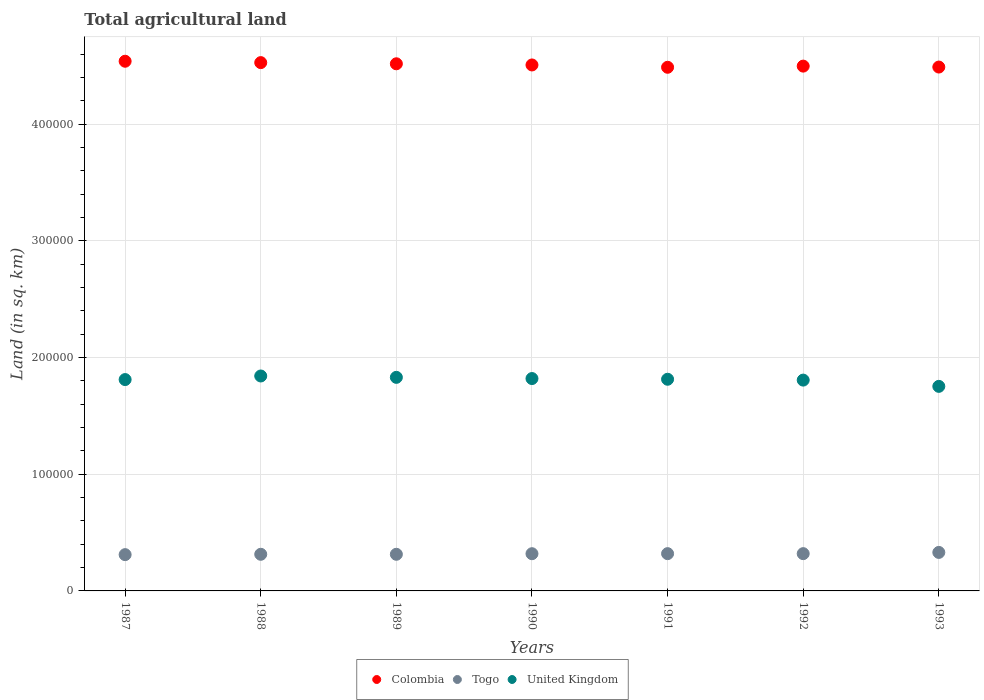What is the total agricultural land in United Kingdom in 1991?
Keep it short and to the point. 1.81e+05. Across all years, what is the maximum total agricultural land in Togo?
Your answer should be compact. 3.30e+04. Across all years, what is the minimum total agricultural land in Togo?
Your answer should be very brief. 3.11e+04. In which year was the total agricultural land in Colombia maximum?
Offer a terse response. 1987. In which year was the total agricultural land in Colombia minimum?
Offer a very short reply. 1991. What is the total total agricultural land in Colombia in the graph?
Provide a short and direct response. 3.16e+06. What is the difference between the total agricultural land in Togo in 1989 and that in 1991?
Provide a short and direct response. -550. What is the difference between the total agricultural land in Colombia in 1991 and the total agricultural land in Togo in 1987?
Keep it short and to the point. 4.18e+05. What is the average total agricultural land in Colombia per year?
Provide a succinct answer. 4.51e+05. In the year 1991, what is the difference between the total agricultural land in Colombia and total agricultural land in United Kingdom?
Your answer should be compact. 2.67e+05. In how many years, is the total agricultural land in United Kingdom greater than 200000 sq.km?
Your response must be concise. 0. What is the ratio of the total agricultural land in Togo in 1988 to that in 1991?
Your response must be concise. 0.98. Is the difference between the total agricultural land in Colombia in 1987 and 1992 greater than the difference between the total agricultural land in United Kingdom in 1987 and 1992?
Offer a very short reply. Yes. What is the difference between the highest and the second highest total agricultural land in Colombia?
Provide a succinct answer. 1180. What is the difference between the highest and the lowest total agricultural land in United Kingdom?
Ensure brevity in your answer.  8890. Is it the case that in every year, the sum of the total agricultural land in United Kingdom and total agricultural land in Colombia  is greater than the total agricultural land in Togo?
Ensure brevity in your answer.  Yes. Is the total agricultural land in United Kingdom strictly less than the total agricultural land in Colombia over the years?
Offer a terse response. Yes. How many years are there in the graph?
Your answer should be compact. 7. Are the values on the major ticks of Y-axis written in scientific E-notation?
Ensure brevity in your answer.  No. Does the graph contain any zero values?
Keep it short and to the point. No. Does the graph contain grids?
Provide a short and direct response. Yes. Where does the legend appear in the graph?
Make the answer very short. Bottom center. What is the title of the graph?
Your answer should be very brief. Total agricultural land. What is the label or title of the X-axis?
Provide a succinct answer. Years. What is the label or title of the Y-axis?
Ensure brevity in your answer.  Land (in sq. km). What is the Land (in sq. km) in Colombia in 1987?
Provide a short and direct response. 4.54e+05. What is the Land (in sq. km) in Togo in 1987?
Make the answer very short. 3.11e+04. What is the Land (in sq. km) of United Kingdom in 1987?
Ensure brevity in your answer.  1.81e+05. What is the Land (in sq. km) of Colombia in 1988?
Provide a short and direct response. 4.53e+05. What is the Land (in sq. km) of Togo in 1988?
Provide a succinct answer. 3.14e+04. What is the Land (in sq. km) in United Kingdom in 1988?
Give a very brief answer. 1.84e+05. What is the Land (in sq. km) in Colombia in 1989?
Make the answer very short. 4.52e+05. What is the Land (in sq. km) of Togo in 1989?
Keep it short and to the point. 3.14e+04. What is the Land (in sq. km) of United Kingdom in 1989?
Provide a succinct answer. 1.83e+05. What is the Land (in sq. km) in Colombia in 1990?
Keep it short and to the point. 4.51e+05. What is the Land (in sq. km) of Togo in 1990?
Provide a succinct answer. 3.19e+04. What is the Land (in sq. km) of United Kingdom in 1990?
Offer a very short reply. 1.82e+05. What is the Land (in sq. km) of Colombia in 1991?
Offer a terse response. 4.49e+05. What is the Land (in sq. km) of Togo in 1991?
Your response must be concise. 3.20e+04. What is the Land (in sq. km) of United Kingdom in 1991?
Provide a succinct answer. 1.81e+05. What is the Land (in sq. km) in Colombia in 1992?
Your answer should be compact. 4.50e+05. What is the Land (in sq. km) of Togo in 1992?
Provide a short and direct response. 3.20e+04. What is the Land (in sq. km) in United Kingdom in 1992?
Provide a succinct answer. 1.81e+05. What is the Land (in sq. km) of Colombia in 1993?
Make the answer very short. 4.49e+05. What is the Land (in sq. km) in Togo in 1993?
Offer a terse response. 3.30e+04. What is the Land (in sq. km) in United Kingdom in 1993?
Ensure brevity in your answer.  1.75e+05. Across all years, what is the maximum Land (in sq. km) in Colombia?
Provide a succinct answer. 4.54e+05. Across all years, what is the maximum Land (in sq. km) in Togo?
Ensure brevity in your answer.  3.30e+04. Across all years, what is the maximum Land (in sq. km) of United Kingdom?
Give a very brief answer. 1.84e+05. Across all years, what is the minimum Land (in sq. km) in Colombia?
Offer a terse response. 4.49e+05. Across all years, what is the minimum Land (in sq. km) of Togo?
Your response must be concise. 3.11e+04. Across all years, what is the minimum Land (in sq. km) in United Kingdom?
Offer a terse response. 1.75e+05. What is the total Land (in sq. km) in Colombia in the graph?
Offer a terse response. 3.16e+06. What is the total Land (in sq. km) of Togo in the graph?
Keep it short and to the point. 2.23e+05. What is the total Land (in sq. km) of United Kingdom in the graph?
Provide a short and direct response. 1.27e+06. What is the difference between the Land (in sq. km) of Colombia in 1987 and that in 1988?
Offer a terse response. 1180. What is the difference between the Land (in sq. km) of Togo in 1987 and that in 1988?
Make the answer very short. -300. What is the difference between the Land (in sq. km) in United Kingdom in 1987 and that in 1988?
Make the answer very short. -3070. What is the difference between the Land (in sq. km) of Colombia in 1987 and that in 1989?
Offer a very short reply. 2180. What is the difference between the Land (in sq. km) of Togo in 1987 and that in 1989?
Your response must be concise. -300. What is the difference between the Land (in sq. km) in United Kingdom in 1987 and that in 1989?
Provide a succinct answer. -1900. What is the difference between the Land (in sq. km) in Colombia in 1987 and that in 1990?
Make the answer very short. 3180. What is the difference between the Land (in sq. km) in Togo in 1987 and that in 1990?
Provide a short and direct response. -800. What is the difference between the Land (in sq. km) of United Kingdom in 1987 and that in 1990?
Make the answer very short. -870. What is the difference between the Land (in sq. km) of Colombia in 1987 and that in 1991?
Provide a short and direct response. 5170. What is the difference between the Land (in sq. km) in Togo in 1987 and that in 1991?
Offer a very short reply. -850. What is the difference between the Land (in sq. km) of United Kingdom in 1987 and that in 1991?
Keep it short and to the point. -270. What is the difference between the Land (in sq. km) in Colombia in 1987 and that in 1992?
Keep it short and to the point. 4180. What is the difference between the Land (in sq. km) of Togo in 1987 and that in 1992?
Make the answer very short. -850. What is the difference between the Land (in sq. km) of United Kingdom in 1987 and that in 1992?
Your answer should be very brief. 460. What is the difference between the Land (in sq. km) of Colombia in 1987 and that in 1993?
Offer a very short reply. 4980. What is the difference between the Land (in sq. km) in Togo in 1987 and that in 1993?
Your response must be concise. -1900. What is the difference between the Land (in sq. km) of United Kingdom in 1987 and that in 1993?
Your answer should be compact. 5820. What is the difference between the Land (in sq. km) in United Kingdom in 1988 and that in 1989?
Your answer should be compact. 1170. What is the difference between the Land (in sq. km) in Togo in 1988 and that in 1990?
Provide a succinct answer. -500. What is the difference between the Land (in sq. km) in United Kingdom in 1988 and that in 1990?
Provide a short and direct response. 2200. What is the difference between the Land (in sq. km) in Colombia in 1988 and that in 1991?
Give a very brief answer. 3990. What is the difference between the Land (in sq. km) of Togo in 1988 and that in 1991?
Provide a succinct answer. -550. What is the difference between the Land (in sq. km) in United Kingdom in 1988 and that in 1991?
Ensure brevity in your answer.  2800. What is the difference between the Land (in sq. km) of Colombia in 1988 and that in 1992?
Offer a terse response. 3000. What is the difference between the Land (in sq. km) in Togo in 1988 and that in 1992?
Your answer should be very brief. -550. What is the difference between the Land (in sq. km) in United Kingdom in 1988 and that in 1992?
Keep it short and to the point. 3530. What is the difference between the Land (in sq. km) of Colombia in 1988 and that in 1993?
Ensure brevity in your answer.  3800. What is the difference between the Land (in sq. km) in Togo in 1988 and that in 1993?
Make the answer very short. -1600. What is the difference between the Land (in sq. km) in United Kingdom in 1988 and that in 1993?
Provide a succinct answer. 8890. What is the difference between the Land (in sq. km) of Colombia in 1989 and that in 1990?
Provide a succinct answer. 1000. What is the difference between the Land (in sq. km) of Togo in 1989 and that in 1990?
Provide a succinct answer. -500. What is the difference between the Land (in sq. km) of United Kingdom in 1989 and that in 1990?
Provide a short and direct response. 1030. What is the difference between the Land (in sq. km) of Colombia in 1989 and that in 1991?
Offer a very short reply. 2990. What is the difference between the Land (in sq. km) in Togo in 1989 and that in 1991?
Provide a succinct answer. -550. What is the difference between the Land (in sq. km) of United Kingdom in 1989 and that in 1991?
Keep it short and to the point. 1630. What is the difference between the Land (in sq. km) of Colombia in 1989 and that in 1992?
Provide a succinct answer. 2000. What is the difference between the Land (in sq. km) in Togo in 1989 and that in 1992?
Your answer should be compact. -550. What is the difference between the Land (in sq. km) in United Kingdom in 1989 and that in 1992?
Your response must be concise. 2360. What is the difference between the Land (in sq. km) of Colombia in 1989 and that in 1993?
Make the answer very short. 2800. What is the difference between the Land (in sq. km) in Togo in 1989 and that in 1993?
Provide a succinct answer. -1600. What is the difference between the Land (in sq. km) in United Kingdom in 1989 and that in 1993?
Provide a succinct answer. 7720. What is the difference between the Land (in sq. km) of Colombia in 1990 and that in 1991?
Offer a very short reply. 1990. What is the difference between the Land (in sq. km) in United Kingdom in 1990 and that in 1991?
Offer a very short reply. 600. What is the difference between the Land (in sq. km) in Togo in 1990 and that in 1992?
Keep it short and to the point. -50. What is the difference between the Land (in sq. km) in United Kingdom in 1990 and that in 1992?
Provide a succinct answer. 1330. What is the difference between the Land (in sq. km) in Colombia in 1990 and that in 1993?
Keep it short and to the point. 1800. What is the difference between the Land (in sq. km) in Togo in 1990 and that in 1993?
Provide a short and direct response. -1100. What is the difference between the Land (in sq. km) of United Kingdom in 1990 and that in 1993?
Ensure brevity in your answer.  6690. What is the difference between the Land (in sq. km) of Colombia in 1991 and that in 1992?
Provide a short and direct response. -990. What is the difference between the Land (in sq. km) of Togo in 1991 and that in 1992?
Give a very brief answer. 0. What is the difference between the Land (in sq. km) in United Kingdom in 1991 and that in 1992?
Your answer should be compact. 730. What is the difference between the Land (in sq. km) in Colombia in 1991 and that in 1993?
Offer a very short reply. -190. What is the difference between the Land (in sq. km) of Togo in 1991 and that in 1993?
Provide a succinct answer. -1050. What is the difference between the Land (in sq. km) in United Kingdom in 1991 and that in 1993?
Provide a short and direct response. 6090. What is the difference between the Land (in sq. km) in Colombia in 1992 and that in 1993?
Make the answer very short. 800. What is the difference between the Land (in sq. km) of Togo in 1992 and that in 1993?
Give a very brief answer. -1050. What is the difference between the Land (in sq. km) of United Kingdom in 1992 and that in 1993?
Your response must be concise. 5360. What is the difference between the Land (in sq. km) of Colombia in 1987 and the Land (in sq. km) of Togo in 1988?
Provide a short and direct response. 4.23e+05. What is the difference between the Land (in sq. km) of Colombia in 1987 and the Land (in sq. km) of United Kingdom in 1988?
Make the answer very short. 2.70e+05. What is the difference between the Land (in sq. km) in Togo in 1987 and the Land (in sq. km) in United Kingdom in 1988?
Offer a terse response. -1.53e+05. What is the difference between the Land (in sq. km) in Colombia in 1987 and the Land (in sq. km) in Togo in 1989?
Ensure brevity in your answer.  4.23e+05. What is the difference between the Land (in sq. km) of Colombia in 1987 and the Land (in sq. km) of United Kingdom in 1989?
Provide a succinct answer. 2.71e+05. What is the difference between the Land (in sq. km) of Togo in 1987 and the Land (in sq. km) of United Kingdom in 1989?
Make the answer very short. -1.52e+05. What is the difference between the Land (in sq. km) of Colombia in 1987 and the Land (in sq. km) of Togo in 1990?
Your response must be concise. 4.22e+05. What is the difference between the Land (in sq. km) of Colombia in 1987 and the Land (in sq. km) of United Kingdom in 1990?
Ensure brevity in your answer.  2.72e+05. What is the difference between the Land (in sq. km) in Togo in 1987 and the Land (in sq. km) in United Kingdom in 1990?
Offer a very short reply. -1.51e+05. What is the difference between the Land (in sq. km) of Colombia in 1987 and the Land (in sq. km) of Togo in 1991?
Your answer should be compact. 4.22e+05. What is the difference between the Land (in sq. km) of Colombia in 1987 and the Land (in sq. km) of United Kingdom in 1991?
Offer a terse response. 2.73e+05. What is the difference between the Land (in sq. km) of Togo in 1987 and the Land (in sq. km) of United Kingdom in 1991?
Provide a short and direct response. -1.50e+05. What is the difference between the Land (in sq. km) in Colombia in 1987 and the Land (in sq. km) in Togo in 1992?
Keep it short and to the point. 4.22e+05. What is the difference between the Land (in sq. km) of Colombia in 1987 and the Land (in sq. km) of United Kingdom in 1992?
Keep it short and to the point. 2.73e+05. What is the difference between the Land (in sq. km) in Togo in 1987 and the Land (in sq. km) in United Kingdom in 1992?
Provide a succinct answer. -1.50e+05. What is the difference between the Land (in sq. km) in Colombia in 1987 and the Land (in sq. km) in Togo in 1993?
Give a very brief answer. 4.21e+05. What is the difference between the Land (in sq. km) of Colombia in 1987 and the Land (in sq. km) of United Kingdom in 1993?
Your answer should be compact. 2.79e+05. What is the difference between the Land (in sq. km) of Togo in 1987 and the Land (in sq. km) of United Kingdom in 1993?
Provide a short and direct response. -1.44e+05. What is the difference between the Land (in sq. km) in Colombia in 1988 and the Land (in sq. km) in Togo in 1989?
Keep it short and to the point. 4.21e+05. What is the difference between the Land (in sq. km) of Colombia in 1988 and the Land (in sq. km) of United Kingdom in 1989?
Make the answer very short. 2.70e+05. What is the difference between the Land (in sq. km) in Togo in 1988 and the Land (in sq. km) in United Kingdom in 1989?
Your response must be concise. -1.52e+05. What is the difference between the Land (in sq. km) of Colombia in 1988 and the Land (in sq. km) of Togo in 1990?
Your answer should be compact. 4.21e+05. What is the difference between the Land (in sq. km) in Colombia in 1988 and the Land (in sq. km) in United Kingdom in 1990?
Keep it short and to the point. 2.71e+05. What is the difference between the Land (in sq. km) of Togo in 1988 and the Land (in sq. km) of United Kingdom in 1990?
Offer a terse response. -1.51e+05. What is the difference between the Land (in sq. km) of Colombia in 1988 and the Land (in sq. km) of Togo in 1991?
Provide a short and direct response. 4.21e+05. What is the difference between the Land (in sq. km) in Colombia in 1988 and the Land (in sq. km) in United Kingdom in 1991?
Ensure brevity in your answer.  2.71e+05. What is the difference between the Land (in sq. km) of Togo in 1988 and the Land (in sq. km) of United Kingdom in 1991?
Offer a very short reply. -1.50e+05. What is the difference between the Land (in sq. km) in Colombia in 1988 and the Land (in sq. km) in Togo in 1992?
Ensure brevity in your answer.  4.21e+05. What is the difference between the Land (in sq. km) in Colombia in 1988 and the Land (in sq. km) in United Kingdom in 1992?
Offer a terse response. 2.72e+05. What is the difference between the Land (in sq. km) in Togo in 1988 and the Land (in sq. km) in United Kingdom in 1992?
Provide a short and direct response. -1.49e+05. What is the difference between the Land (in sq. km) of Colombia in 1988 and the Land (in sq. km) of Togo in 1993?
Provide a succinct answer. 4.20e+05. What is the difference between the Land (in sq. km) in Colombia in 1988 and the Land (in sq. km) in United Kingdom in 1993?
Keep it short and to the point. 2.77e+05. What is the difference between the Land (in sq. km) of Togo in 1988 and the Land (in sq. km) of United Kingdom in 1993?
Offer a very short reply. -1.44e+05. What is the difference between the Land (in sq. km) of Colombia in 1989 and the Land (in sq. km) of Togo in 1990?
Provide a succinct answer. 4.20e+05. What is the difference between the Land (in sq. km) in Colombia in 1989 and the Land (in sq. km) in United Kingdom in 1990?
Ensure brevity in your answer.  2.70e+05. What is the difference between the Land (in sq. km) in Togo in 1989 and the Land (in sq. km) in United Kingdom in 1990?
Offer a terse response. -1.51e+05. What is the difference between the Land (in sq. km) of Colombia in 1989 and the Land (in sq. km) of Togo in 1991?
Offer a terse response. 4.20e+05. What is the difference between the Land (in sq. km) in Colombia in 1989 and the Land (in sq. km) in United Kingdom in 1991?
Provide a short and direct response. 2.70e+05. What is the difference between the Land (in sq. km) of Togo in 1989 and the Land (in sq. km) of United Kingdom in 1991?
Make the answer very short. -1.50e+05. What is the difference between the Land (in sq. km) in Colombia in 1989 and the Land (in sq. km) in Togo in 1992?
Offer a very short reply. 4.20e+05. What is the difference between the Land (in sq. km) in Colombia in 1989 and the Land (in sq. km) in United Kingdom in 1992?
Offer a terse response. 2.71e+05. What is the difference between the Land (in sq. km) of Togo in 1989 and the Land (in sq. km) of United Kingdom in 1992?
Keep it short and to the point. -1.49e+05. What is the difference between the Land (in sq. km) in Colombia in 1989 and the Land (in sq. km) in Togo in 1993?
Provide a succinct answer. 4.19e+05. What is the difference between the Land (in sq. km) in Colombia in 1989 and the Land (in sq. km) in United Kingdom in 1993?
Make the answer very short. 2.76e+05. What is the difference between the Land (in sq. km) of Togo in 1989 and the Land (in sq. km) of United Kingdom in 1993?
Keep it short and to the point. -1.44e+05. What is the difference between the Land (in sq. km) of Colombia in 1990 and the Land (in sq. km) of Togo in 1991?
Ensure brevity in your answer.  4.19e+05. What is the difference between the Land (in sq. km) in Colombia in 1990 and the Land (in sq. km) in United Kingdom in 1991?
Offer a terse response. 2.69e+05. What is the difference between the Land (in sq. km) in Togo in 1990 and the Land (in sq. km) in United Kingdom in 1991?
Provide a succinct answer. -1.50e+05. What is the difference between the Land (in sq. km) of Colombia in 1990 and the Land (in sq. km) of Togo in 1992?
Offer a terse response. 4.19e+05. What is the difference between the Land (in sq. km) in Colombia in 1990 and the Land (in sq. km) in United Kingdom in 1992?
Provide a short and direct response. 2.70e+05. What is the difference between the Land (in sq. km) of Togo in 1990 and the Land (in sq. km) of United Kingdom in 1992?
Make the answer very short. -1.49e+05. What is the difference between the Land (in sq. km) of Colombia in 1990 and the Land (in sq. km) of Togo in 1993?
Provide a short and direct response. 4.18e+05. What is the difference between the Land (in sq. km) in Colombia in 1990 and the Land (in sq. km) in United Kingdom in 1993?
Your answer should be compact. 2.75e+05. What is the difference between the Land (in sq. km) in Togo in 1990 and the Land (in sq. km) in United Kingdom in 1993?
Provide a short and direct response. -1.43e+05. What is the difference between the Land (in sq. km) of Colombia in 1991 and the Land (in sq. km) of Togo in 1992?
Provide a succinct answer. 4.17e+05. What is the difference between the Land (in sq. km) of Colombia in 1991 and the Land (in sq. km) of United Kingdom in 1992?
Keep it short and to the point. 2.68e+05. What is the difference between the Land (in sq. km) of Togo in 1991 and the Land (in sq. km) of United Kingdom in 1992?
Keep it short and to the point. -1.49e+05. What is the difference between the Land (in sq. km) of Colombia in 1991 and the Land (in sq. km) of Togo in 1993?
Your response must be concise. 4.16e+05. What is the difference between the Land (in sq. km) of Colombia in 1991 and the Land (in sq. km) of United Kingdom in 1993?
Keep it short and to the point. 2.74e+05. What is the difference between the Land (in sq. km) in Togo in 1991 and the Land (in sq. km) in United Kingdom in 1993?
Give a very brief answer. -1.43e+05. What is the difference between the Land (in sq. km) of Colombia in 1992 and the Land (in sq. km) of Togo in 1993?
Your response must be concise. 4.17e+05. What is the difference between the Land (in sq. km) in Colombia in 1992 and the Land (in sq. km) in United Kingdom in 1993?
Your response must be concise. 2.74e+05. What is the difference between the Land (in sq. km) in Togo in 1992 and the Land (in sq. km) in United Kingdom in 1993?
Keep it short and to the point. -1.43e+05. What is the average Land (in sq. km) of Colombia per year?
Offer a very short reply. 4.51e+05. What is the average Land (in sq. km) of Togo per year?
Give a very brief answer. 3.18e+04. What is the average Land (in sq. km) in United Kingdom per year?
Keep it short and to the point. 1.81e+05. In the year 1987, what is the difference between the Land (in sq. km) of Colombia and Land (in sq. km) of Togo?
Keep it short and to the point. 4.23e+05. In the year 1987, what is the difference between the Land (in sq. km) of Colombia and Land (in sq. km) of United Kingdom?
Your answer should be compact. 2.73e+05. In the year 1987, what is the difference between the Land (in sq. km) in Togo and Land (in sq. km) in United Kingdom?
Give a very brief answer. -1.50e+05. In the year 1988, what is the difference between the Land (in sq. km) of Colombia and Land (in sq. km) of Togo?
Your answer should be very brief. 4.21e+05. In the year 1988, what is the difference between the Land (in sq. km) in Colombia and Land (in sq. km) in United Kingdom?
Offer a very short reply. 2.69e+05. In the year 1988, what is the difference between the Land (in sq. km) of Togo and Land (in sq. km) of United Kingdom?
Your answer should be very brief. -1.53e+05. In the year 1989, what is the difference between the Land (in sq. km) of Colombia and Land (in sq. km) of Togo?
Make the answer very short. 4.20e+05. In the year 1989, what is the difference between the Land (in sq. km) of Colombia and Land (in sq. km) of United Kingdom?
Provide a succinct answer. 2.69e+05. In the year 1989, what is the difference between the Land (in sq. km) of Togo and Land (in sq. km) of United Kingdom?
Your answer should be very brief. -1.52e+05. In the year 1990, what is the difference between the Land (in sq. km) of Colombia and Land (in sq. km) of Togo?
Offer a terse response. 4.19e+05. In the year 1990, what is the difference between the Land (in sq. km) of Colombia and Land (in sq. km) of United Kingdom?
Provide a short and direct response. 2.69e+05. In the year 1990, what is the difference between the Land (in sq. km) in Togo and Land (in sq. km) in United Kingdom?
Provide a short and direct response. -1.50e+05. In the year 1991, what is the difference between the Land (in sq. km) of Colombia and Land (in sq. km) of Togo?
Give a very brief answer. 4.17e+05. In the year 1991, what is the difference between the Land (in sq. km) of Colombia and Land (in sq. km) of United Kingdom?
Keep it short and to the point. 2.67e+05. In the year 1991, what is the difference between the Land (in sq. km) of Togo and Land (in sq. km) of United Kingdom?
Keep it short and to the point. -1.49e+05. In the year 1992, what is the difference between the Land (in sq. km) of Colombia and Land (in sq. km) of Togo?
Keep it short and to the point. 4.18e+05. In the year 1992, what is the difference between the Land (in sq. km) of Colombia and Land (in sq. km) of United Kingdom?
Ensure brevity in your answer.  2.69e+05. In the year 1992, what is the difference between the Land (in sq. km) in Togo and Land (in sq. km) in United Kingdom?
Keep it short and to the point. -1.49e+05. In the year 1993, what is the difference between the Land (in sq. km) of Colombia and Land (in sq. km) of Togo?
Provide a short and direct response. 4.16e+05. In the year 1993, what is the difference between the Land (in sq. km) of Colombia and Land (in sq. km) of United Kingdom?
Provide a short and direct response. 2.74e+05. In the year 1993, what is the difference between the Land (in sq. km) of Togo and Land (in sq. km) of United Kingdom?
Give a very brief answer. -1.42e+05. What is the ratio of the Land (in sq. km) of Colombia in 1987 to that in 1988?
Your answer should be very brief. 1. What is the ratio of the Land (in sq. km) in United Kingdom in 1987 to that in 1988?
Your response must be concise. 0.98. What is the ratio of the Land (in sq. km) of Colombia in 1987 to that in 1989?
Provide a succinct answer. 1. What is the ratio of the Land (in sq. km) in United Kingdom in 1987 to that in 1989?
Keep it short and to the point. 0.99. What is the ratio of the Land (in sq. km) of Colombia in 1987 to that in 1990?
Your answer should be compact. 1.01. What is the ratio of the Land (in sq. km) in Togo in 1987 to that in 1990?
Provide a short and direct response. 0.97. What is the ratio of the Land (in sq. km) in Colombia in 1987 to that in 1991?
Keep it short and to the point. 1.01. What is the ratio of the Land (in sq. km) in Togo in 1987 to that in 1991?
Keep it short and to the point. 0.97. What is the ratio of the Land (in sq. km) in Colombia in 1987 to that in 1992?
Ensure brevity in your answer.  1.01. What is the ratio of the Land (in sq. km) in Togo in 1987 to that in 1992?
Keep it short and to the point. 0.97. What is the ratio of the Land (in sq. km) of United Kingdom in 1987 to that in 1992?
Give a very brief answer. 1. What is the ratio of the Land (in sq. km) in Colombia in 1987 to that in 1993?
Offer a terse response. 1.01. What is the ratio of the Land (in sq. km) in Togo in 1987 to that in 1993?
Your response must be concise. 0.94. What is the ratio of the Land (in sq. km) of United Kingdom in 1987 to that in 1993?
Offer a very short reply. 1.03. What is the ratio of the Land (in sq. km) of Colombia in 1988 to that in 1989?
Provide a short and direct response. 1. What is the ratio of the Land (in sq. km) of United Kingdom in 1988 to that in 1989?
Your response must be concise. 1.01. What is the ratio of the Land (in sq. km) of Colombia in 1988 to that in 1990?
Provide a short and direct response. 1. What is the ratio of the Land (in sq. km) of Togo in 1988 to that in 1990?
Ensure brevity in your answer.  0.98. What is the ratio of the Land (in sq. km) of United Kingdom in 1988 to that in 1990?
Give a very brief answer. 1.01. What is the ratio of the Land (in sq. km) of Colombia in 1988 to that in 1991?
Provide a succinct answer. 1.01. What is the ratio of the Land (in sq. km) in Togo in 1988 to that in 1991?
Your response must be concise. 0.98. What is the ratio of the Land (in sq. km) in United Kingdom in 1988 to that in 1991?
Offer a terse response. 1.02. What is the ratio of the Land (in sq. km) in Colombia in 1988 to that in 1992?
Give a very brief answer. 1.01. What is the ratio of the Land (in sq. km) in Togo in 1988 to that in 1992?
Provide a succinct answer. 0.98. What is the ratio of the Land (in sq. km) of United Kingdom in 1988 to that in 1992?
Make the answer very short. 1.02. What is the ratio of the Land (in sq. km) in Colombia in 1988 to that in 1993?
Your response must be concise. 1.01. What is the ratio of the Land (in sq. km) of Togo in 1988 to that in 1993?
Offer a terse response. 0.95. What is the ratio of the Land (in sq. km) in United Kingdom in 1988 to that in 1993?
Give a very brief answer. 1.05. What is the ratio of the Land (in sq. km) in Togo in 1989 to that in 1990?
Give a very brief answer. 0.98. What is the ratio of the Land (in sq. km) of United Kingdom in 1989 to that in 1990?
Keep it short and to the point. 1.01. What is the ratio of the Land (in sq. km) of Colombia in 1989 to that in 1991?
Provide a short and direct response. 1.01. What is the ratio of the Land (in sq. km) of Togo in 1989 to that in 1991?
Provide a short and direct response. 0.98. What is the ratio of the Land (in sq. km) of United Kingdom in 1989 to that in 1991?
Give a very brief answer. 1.01. What is the ratio of the Land (in sq. km) in Togo in 1989 to that in 1992?
Your answer should be compact. 0.98. What is the ratio of the Land (in sq. km) in United Kingdom in 1989 to that in 1992?
Provide a succinct answer. 1.01. What is the ratio of the Land (in sq. km) of Colombia in 1989 to that in 1993?
Provide a short and direct response. 1.01. What is the ratio of the Land (in sq. km) of Togo in 1989 to that in 1993?
Provide a short and direct response. 0.95. What is the ratio of the Land (in sq. km) of United Kingdom in 1989 to that in 1993?
Your answer should be compact. 1.04. What is the ratio of the Land (in sq. km) in Togo in 1990 to that in 1992?
Provide a short and direct response. 1. What is the ratio of the Land (in sq. km) in United Kingdom in 1990 to that in 1992?
Ensure brevity in your answer.  1.01. What is the ratio of the Land (in sq. km) of Togo in 1990 to that in 1993?
Make the answer very short. 0.97. What is the ratio of the Land (in sq. km) in United Kingdom in 1990 to that in 1993?
Your answer should be very brief. 1.04. What is the ratio of the Land (in sq. km) of Togo in 1991 to that in 1992?
Make the answer very short. 1. What is the ratio of the Land (in sq. km) in United Kingdom in 1991 to that in 1992?
Offer a terse response. 1. What is the ratio of the Land (in sq. km) of Togo in 1991 to that in 1993?
Provide a succinct answer. 0.97. What is the ratio of the Land (in sq. km) in United Kingdom in 1991 to that in 1993?
Offer a very short reply. 1.03. What is the ratio of the Land (in sq. km) in Colombia in 1992 to that in 1993?
Your answer should be compact. 1. What is the ratio of the Land (in sq. km) of Togo in 1992 to that in 1993?
Your answer should be compact. 0.97. What is the ratio of the Land (in sq. km) of United Kingdom in 1992 to that in 1993?
Keep it short and to the point. 1.03. What is the difference between the highest and the second highest Land (in sq. km) in Colombia?
Ensure brevity in your answer.  1180. What is the difference between the highest and the second highest Land (in sq. km) in Togo?
Keep it short and to the point. 1050. What is the difference between the highest and the second highest Land (in sq. km) in United Kingdom?
Offer a very short reply. 1170. What is the difference between the highest and the lowest Land (in sq. km) of Colombia?
Provide a succinct answer. 5170. What is the difference between the highest and the lowest Land (in sq. km) in Togo?
Offer a terse response. 1900. What is the difference between the highest and the lowest Land (in sq. km) in United Kingdom?
Keep it short and to the point. 8890. 